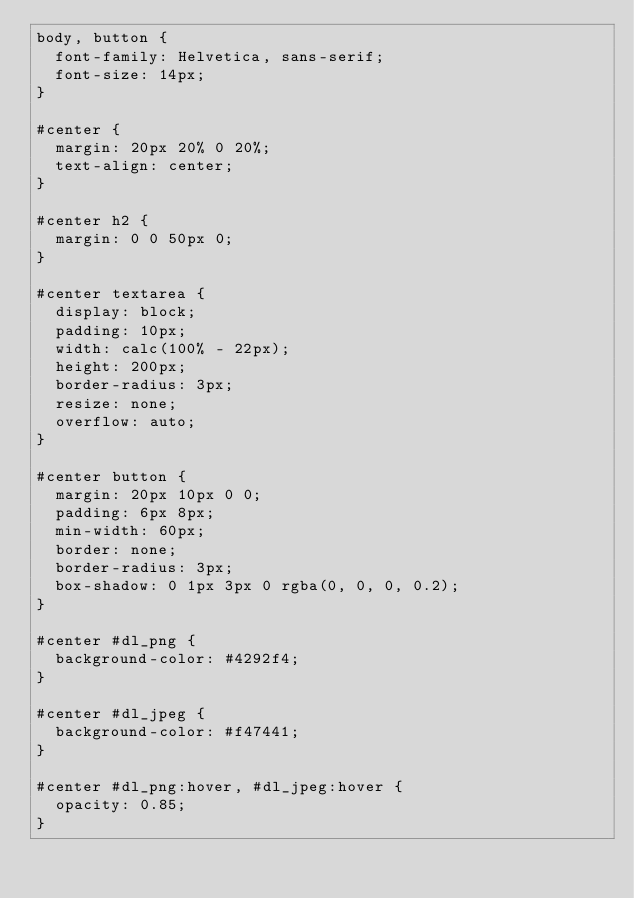<code> <loc_0><loc_0><loc_500><loc_500><_CSS_>body, button {
	font-family: Helvetica, sans-serif;
	font-size: 14px;
}

#center {
	margin: 20px 20% 0 20%;
	text-align: center;
}

#center h2 {
	margin: 0 0 50px 0;
}

#center textarea {
	display: block;
	padding: 10px;
	width: calc(100% - 22px);
	height: 200px;
	border-radius: 3px;
	resize: none;
	overflow: auto;
}

#center button {
	margin: 20px 10px 0 0;
	padding: 6px 8px;
	min-width: 60px;
	border: none;
	border-radius: 3px;
	box-shadow: 0 1px 3px 0 rgba(0, 0, 0, 0.2);
}

#center #dl_png {
	background-color: #4292f4;
}

#center #dl_jpeg {
	background-color: #f47441;
}

#center #dl_png:hover, #dl_jpeg:hover {
	opacity: 0.85;
}</code> 